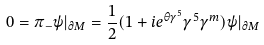Convert formula to latex. <formula><loc_0><loc_0><loc_500><loc_500>0 = \pi _ { - } \psi | _ { \partial M } = \frac { 1 } { 2 } ( 1 + i e ^ { \theta \gamma ^ { 5 } } \gamma ^ { 5 } \gamma ^ { m } ) \psi | _ { \partial M }</formula> 